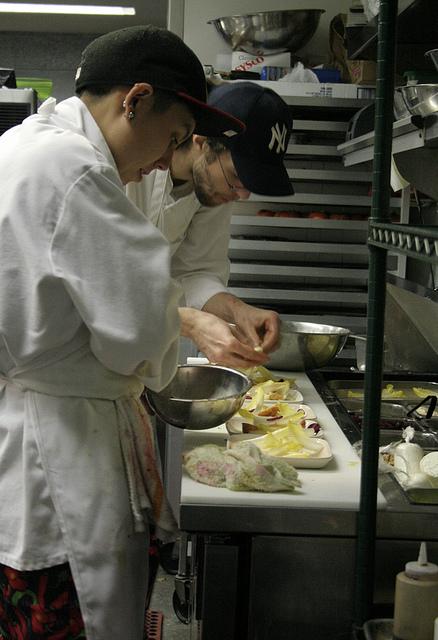What cuisine is being prepared?
Write a very short answer. Salad. Is this picture in color?
Concise answer only. Yes. How many people are visible?
Write a very short answer. 2. How many bowls are there?
Quick response, please. 2. What team emblem is on the man's hat?
Keep it brief. Ny. What color are the men's aprons?
Write a very short answer. White. What fruit is on the table?
Answer briefly. Pears. What are the people doing?
Short answer required. Cooking. What is in the oven?
Concise answer only. Food. 